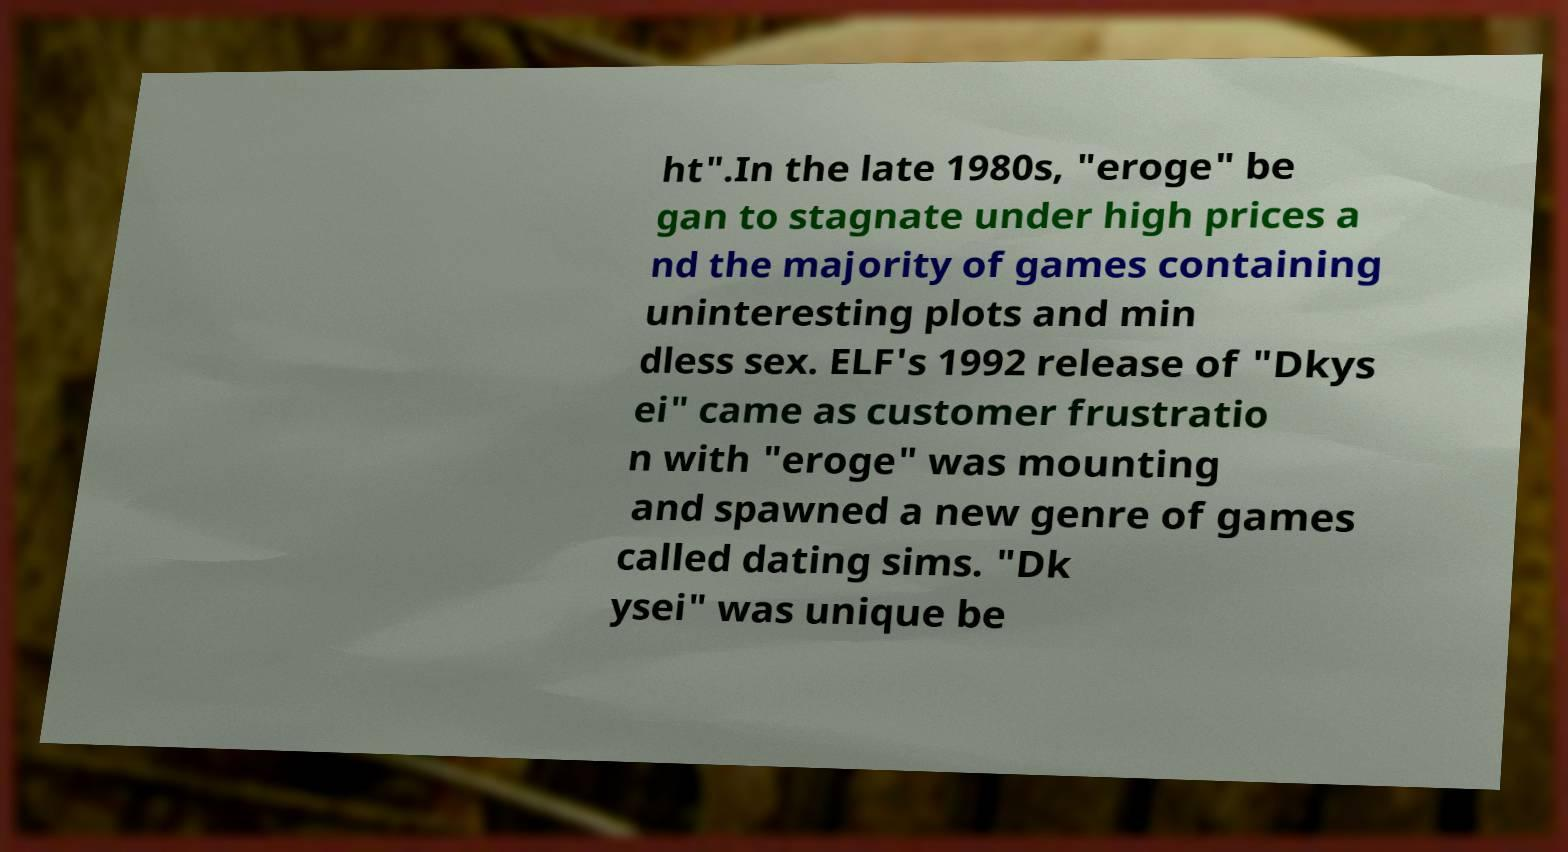Can you read and provide the text displayed in the image?This photo seems to have some interesting text. Can you extract and type it out for me? ht".In the late 1980s, "eroge" be gan to stagnate under high prices a nd the majority of games containing uninteresting plots and min dless sex. ELF's 1992 release of "Dkys ei" came as customer frustratio n with "eroge" was mounting and spawned a new genre of games called dating sims. "Dk ysei" was unique be 